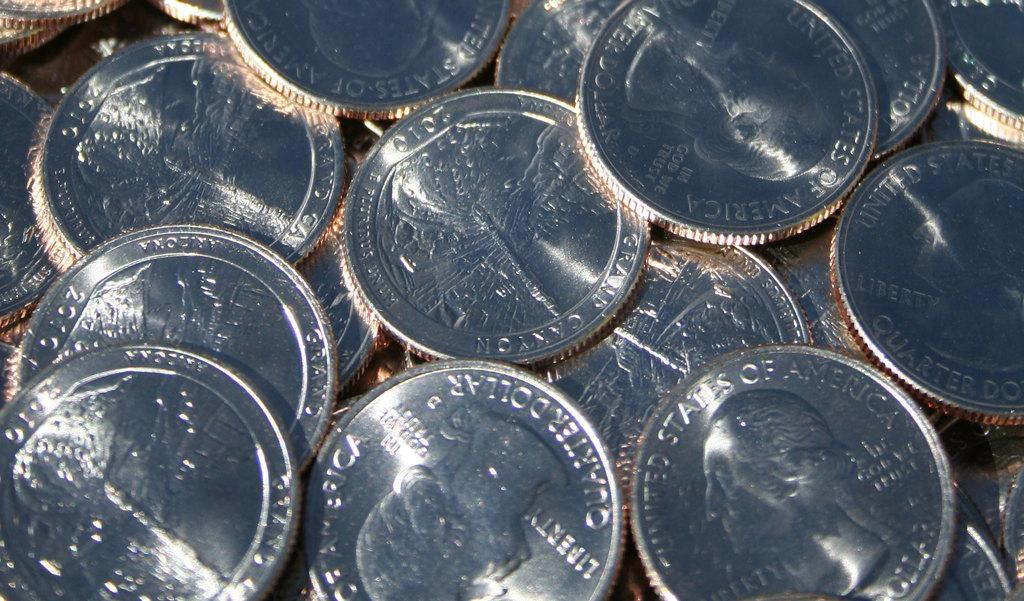Provide a one-sentence caption for the provided image. A bunch of quarters featuring President George Washington are spread out. 